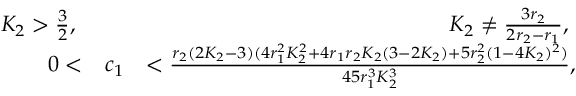<formula> <loc_0><loc_0><loc_500><loc_500>\begin{array} { r l r } { K _ { 2 } > \frac { 3 } { 2 } , } & { K _ { 2 } \neq \frac { 3 r _ { 2 } } { 2 r _ { 2 } - r _ { 1 } } , } \\ { 0 < } & { c _ { 1 } } & { < \frac { r _ { 2 } ( 2 K _ { 2 } - 3 ) ( 4 r _ { 1 } ^ { 2 } K _ { 2 } ^ { 2 } + 4 r _ { 1 } r _ { 2 } K _ { 2 } ( 3 - 2 K _ { 2 } ) + 5 r _ { 2 } ^ { 2 } ( 1 - 4 K _ { 2 } ) ^ { 2 } ) } { 4 5 r _ { 1 } ^ { 3 } K _ { 2 } ^ { 3 } } , } \end{array}</formula> 